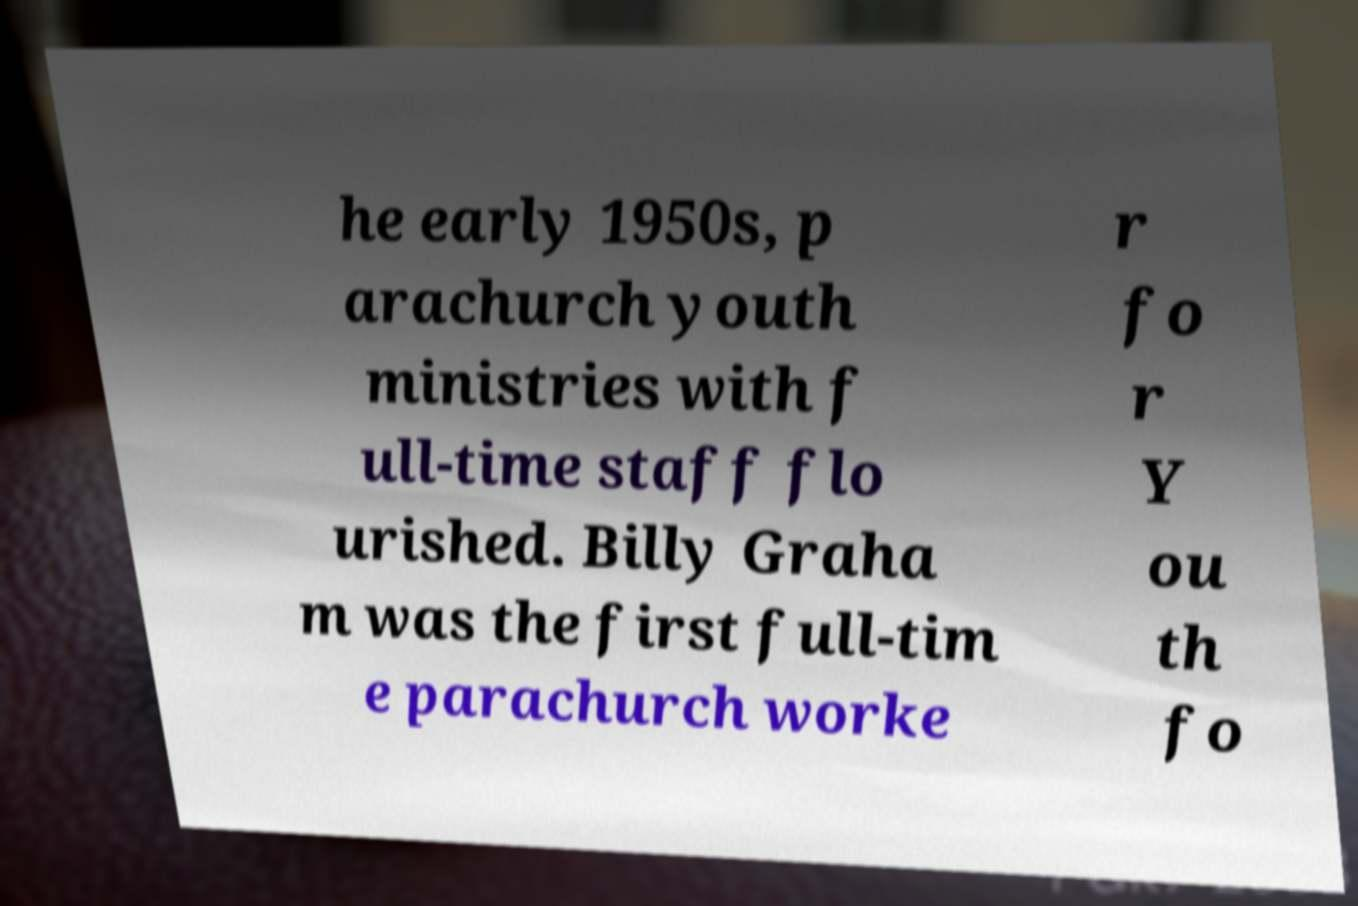For documentation purposes, I need the text within this image transcribed. Could you provide that? he early 1950s, p arachurch youth ministries with f ull-time staff flo urished. Billy Graha m was the first full-tim e parachurch worke r fo r Y ou th fo 